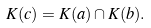Convert formula to latex. <formula><loc_0><loc_0><loc_500><loc_500>K ( c ) = K ( a ) \cap K ( b ) .</formula> 